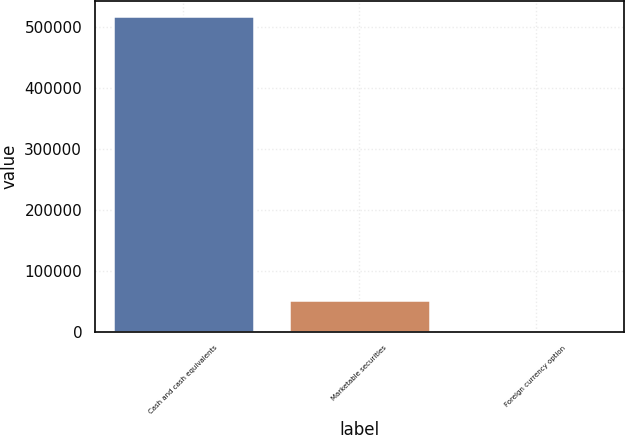Convert chart to OTSL. <chart><loc_0><loc_0><loc_500><loc_500><bar_chart><fcel>Cash and cash equivalents<fcel>Marketable securities<fcel>Foreign currency option<nl><fcel>517654<fcel>51948.1<fcel>203<nl></chart> 